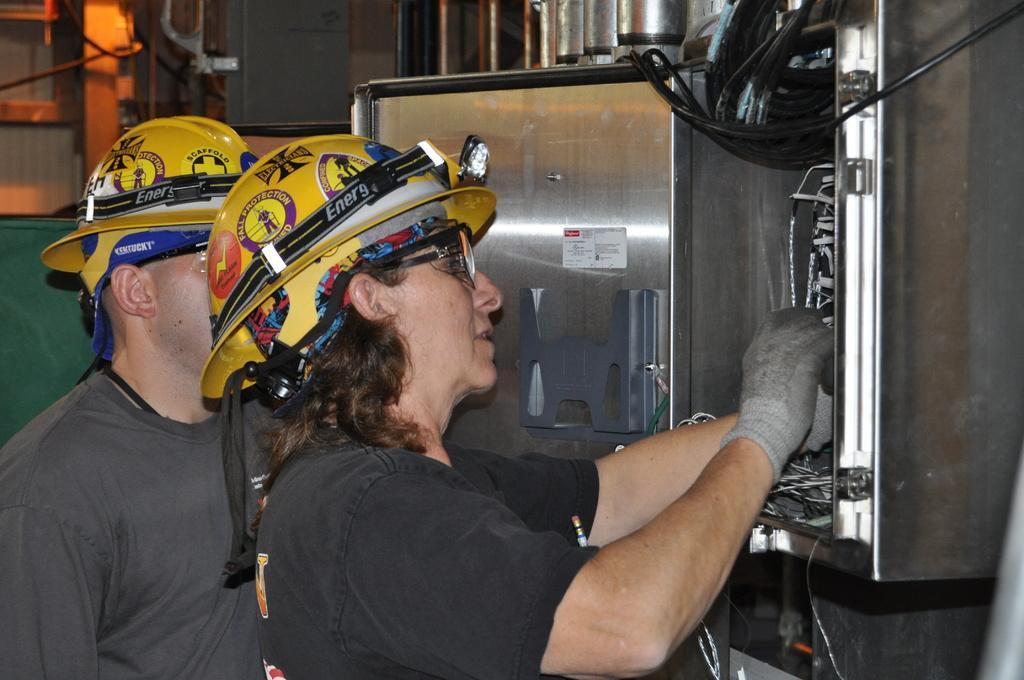How would you summarize this image in a sentence or two? In this picture I can see two persons with helmets, there is a person repairing a fuse box, and in the background there are some objects. 